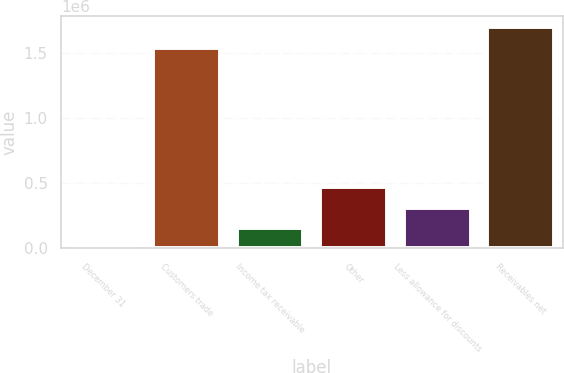Convert chart to OTSL. <chart><loc_0><loc_0><loc_500><loc_500><bar_chart><fcel>December 31<fcel>Customers trade<fcel>Income tax receivable<fcel>Other<fcel>Less allowance for discounts<fcel>Receivables net<nl><fcel>2017<fcel>1.53835e+06<fcel>157631<fcel>468860<fcel>313245<fcel>1.69396e+06<nl></chart> 